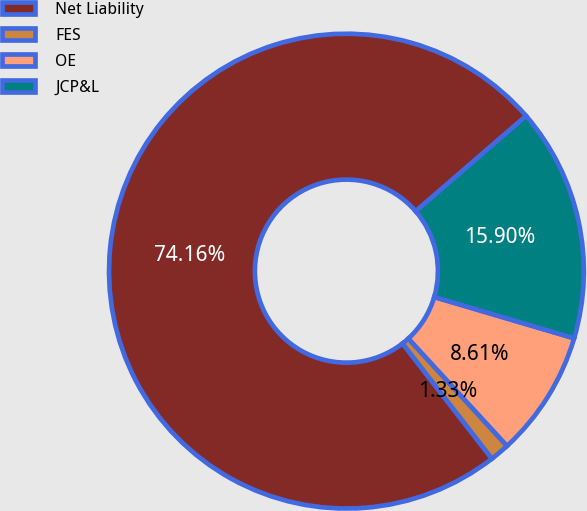Convert chart. <chart><loc_0><loc_0><loc_500><loc_500><pie_chart><fcel>Net Liability<fcel>FES<fcel>OE<fcel>JCP&L<nl><fcel>74.17%<fcel>1.33%<fcel>8.61%<fcel>15.9%<nl></chart> 